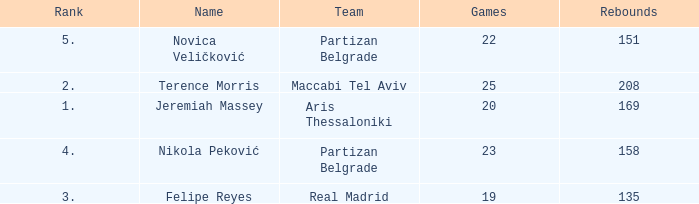What is the number of Games for the Maccabi Tel Aviv Team with less than 208 Rebounds? None. 